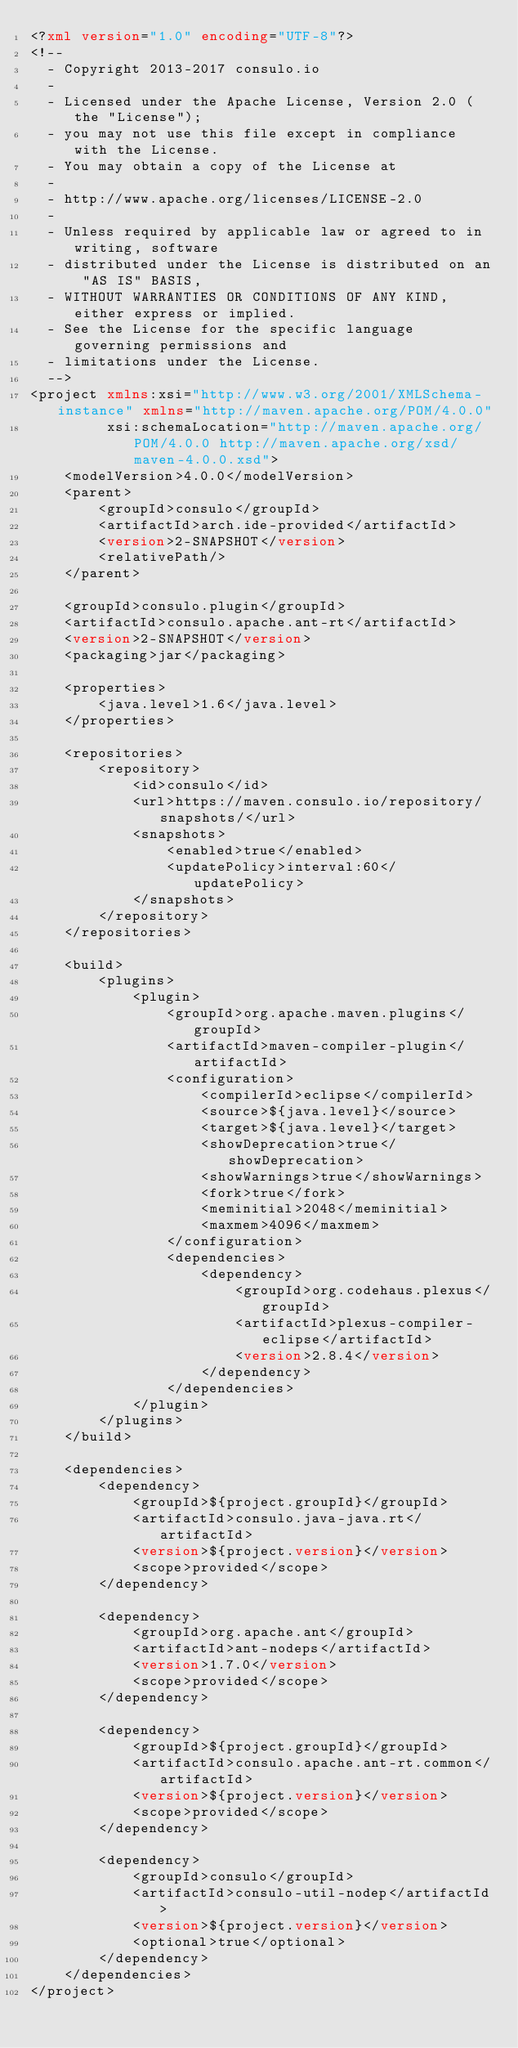<code> <loc_0><loc_0><loc_500><loc_500><_XML_><?xml version="1.0" encoding="UTF-8"?>
<!--
  - Copyright 2013-2017 consulo.io
  -
  - Licensed under the Apache License, Version 2.0 (the "License");
  - you may not use this file except in compliance with the License.
  - You may obtain a copy of the License at
  -
  - http://www.apache.org/licenses/LICENSE-2.0
  -
  - Unless required by applicable law or agreed to in writing, software
  - distributed under the License is distributed on an "AS IS" BASIS,
  - WITHOUT WARRANTIES OR CONDITIONS OF ANY KIND, either express or implied.
  - See the License for the specific language governing permissions and
  - limitations under the License.
  -->
<project xmlns:xsi="http://www.w3.org/2001/XMLSchema-instance" xmlns="http://maven.apache.org/POM/4.0.0"
		 xsi:schemaLocation="http://maven.apache.org/POM/4.0.0 http://maven.apache.org/xsd/maven-4.0.0.xsd">
	<modelVersion>4.0.0</modelVersion>
	<parent>
		<groupId>consulo</groupId>
		<artifactId>arch.ide-provided</artifactId>
		<version>2-SNAPSHOT</version>
		<relativePath/>
	</parent>

	<groupId>consulo.plugin</groupId>
	<artifactId>consulo.apache.ant-rt</artifactId>
	<version>2-SNAPSHOT</version>
	<packaging>jar</packaging>

	<properties>
		<java.level>1.6</java.level>
	</properties>

	<repositories>
		<repository>
			<id>consulo</id>
			<url>https://maven.consulo.io/repository/snapshots/</url>
			<snapshots>
				<enabled>true</enabled>
				<updatePolicy>interval:60</updatePolicy>
			</snapshots>
		</repository>
	</repositories>

	<build>
		<plugins>
			<plugin>
				<groupId>org.apache.maven.plugins</groupId>
				<artifactId>maven-compiler-plugin</artifactId>
				<configuration>
					<compilerId>eclipse</compilerId>
					<source>${java.level}</source>
					<target>${java.level}</target>
					<showDeprecation>true</showDeprecation>
					<showWarnings>true</showWarnings>
					<fork>true</fork>
					<meminitial>2048</meminitial>
					<maxmem>4096</maxmem>
				</configuration>
				<dependencies>
					<dependency>
						<groupId>org.codehaus.plexus</groupId>
						<artifactId>plexus-compiler-eclipse</artifactId>
						<version>2.8.4</version>
					</dependency>
				</dependencies>
			</plugin>
		</plugins>
	</build>

	<dependencies>
		<dependency>
			<groupId>${project.groupId}</groupId>
			<artifactId>consulo.java-java.rt</artifactId>
			<version>${project.version}</version>
			<scope>provided</scope>
		</dependency>

		<dependency>
			<groupId>org.apache.ant</groupId>
			<artifactId>ant-nodeps</artifactId>
			<version>1.7.0</version>
			<scope>provided</scope>
		</dependency>

		<dependency>
			<groupId>${project.groupId}</groupId>
			<artifactId>consulo.apache.ant-rt.common</artifactId>
			<version>${project.version}</version>
			<scope>provided</scope>
		</dependency>

		<dependency>
			<groupId>consulo</groupId>
			<artifactId>consulo-util-nodep</artifactId>
			<version>${project.version}</version>
			<optional>true</optional>
		</dependency>
	</dependencies>
</project></code> 